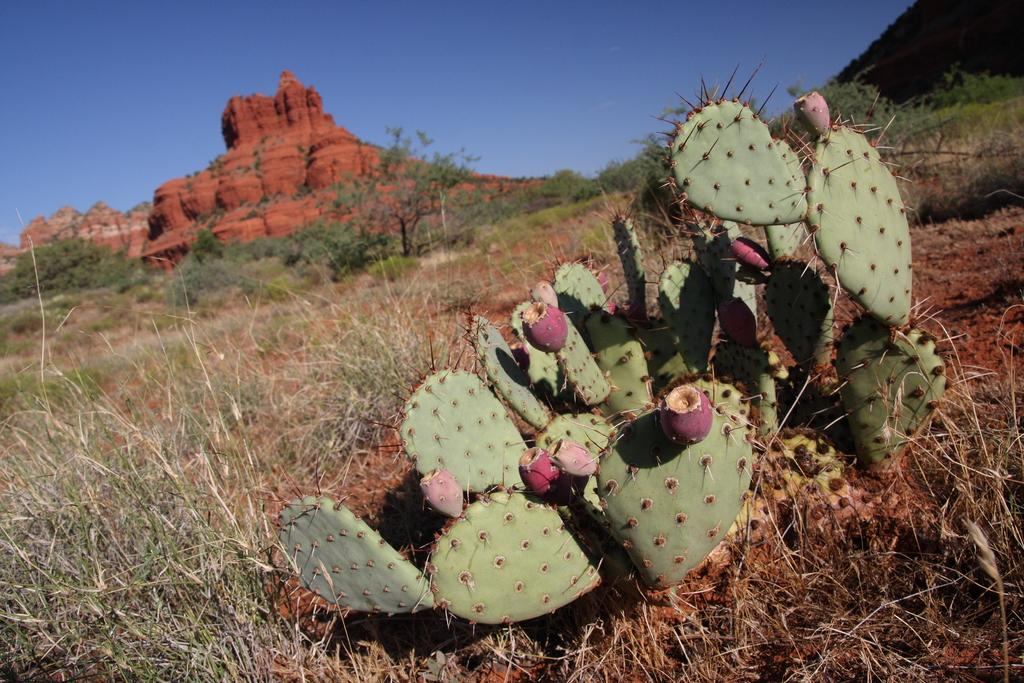What type of plant is in the image? There is a cactus plant in the image. What type of vegetation is present besides the cactus? There is grass in the image. What can be seen in the distance in the image? There is a mountain in the background of the image. What is the condition of the sky in the image? The sky is clear in the image. What time of day is the request being made in the image? There is no request being made in the image, as it only features a cactus plant, grass, a mountain, and a clear sky. 